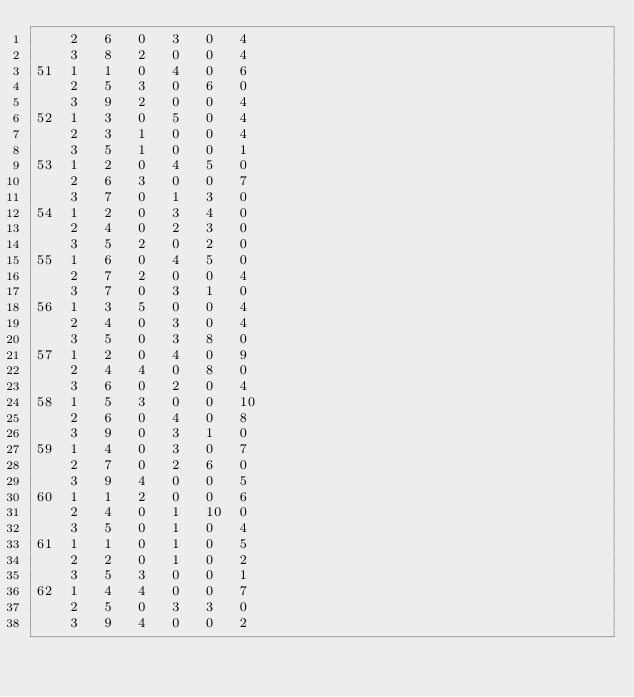<code> <loc_0><loc_0><loc_500><loc_500><_ObjectiveC_>	2	6	0	3	0	4	
	3	8	2	0	0	4	
51	1	1	0	4	0	6	
	2	5	3	0	6	0	
	3	9	2	0	0	4	
52	1	3	0	5	0	4	
	2	3	1	0	0	4	
	3	5	1	0	0	1	
53	1	2	0	4	5	0	
	2	6	3	0	0	7	
	3	7	0	1	3	0	
54	1	2	0	3	4	0	
	2	4	0	2	3	0	
	3	5	2	0	2	0	
55	1	6	0	4	5	0	
	2	7	2	0	0	4	
	3	7	0	3	1	0	
56	1	3	5	0	0	4	
	2	4	0	3	0	4	
	3	5	0	3	8	0	
57	1	2	0	4	0	9	
	2	4	4	0	8	0	
	3	6	0	2	0	4	
58	1	5	3	0	0	10	
	2	6	0	4	0	8	
	3	9	0	3	1	0	
59	1	4	0	3	0	7	
	2	7	0	2	6	0	
	3	9	4	0	0	5	
60	1	1	2	0	0	6	
	2	4	0	1	10	0	
	3	5	0	1	0	4	
61	1	1	0	1	0	5	
	2	2	0	1	0	2	
	3	5	3	0	0	1	
62	1	4	4	0	0	7	
	2	5	0	3	3	0	
	3	9	4	0	0	2	</code> 